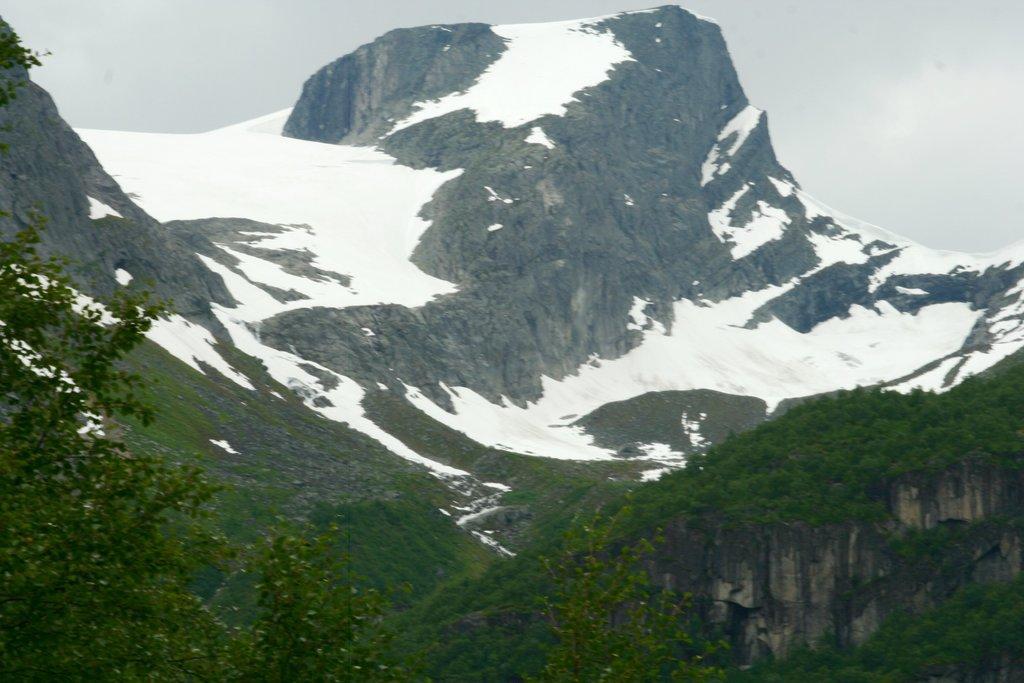Could you give a brief overview of what you see in this image? In this image there are trees and mountains covered with snow. 